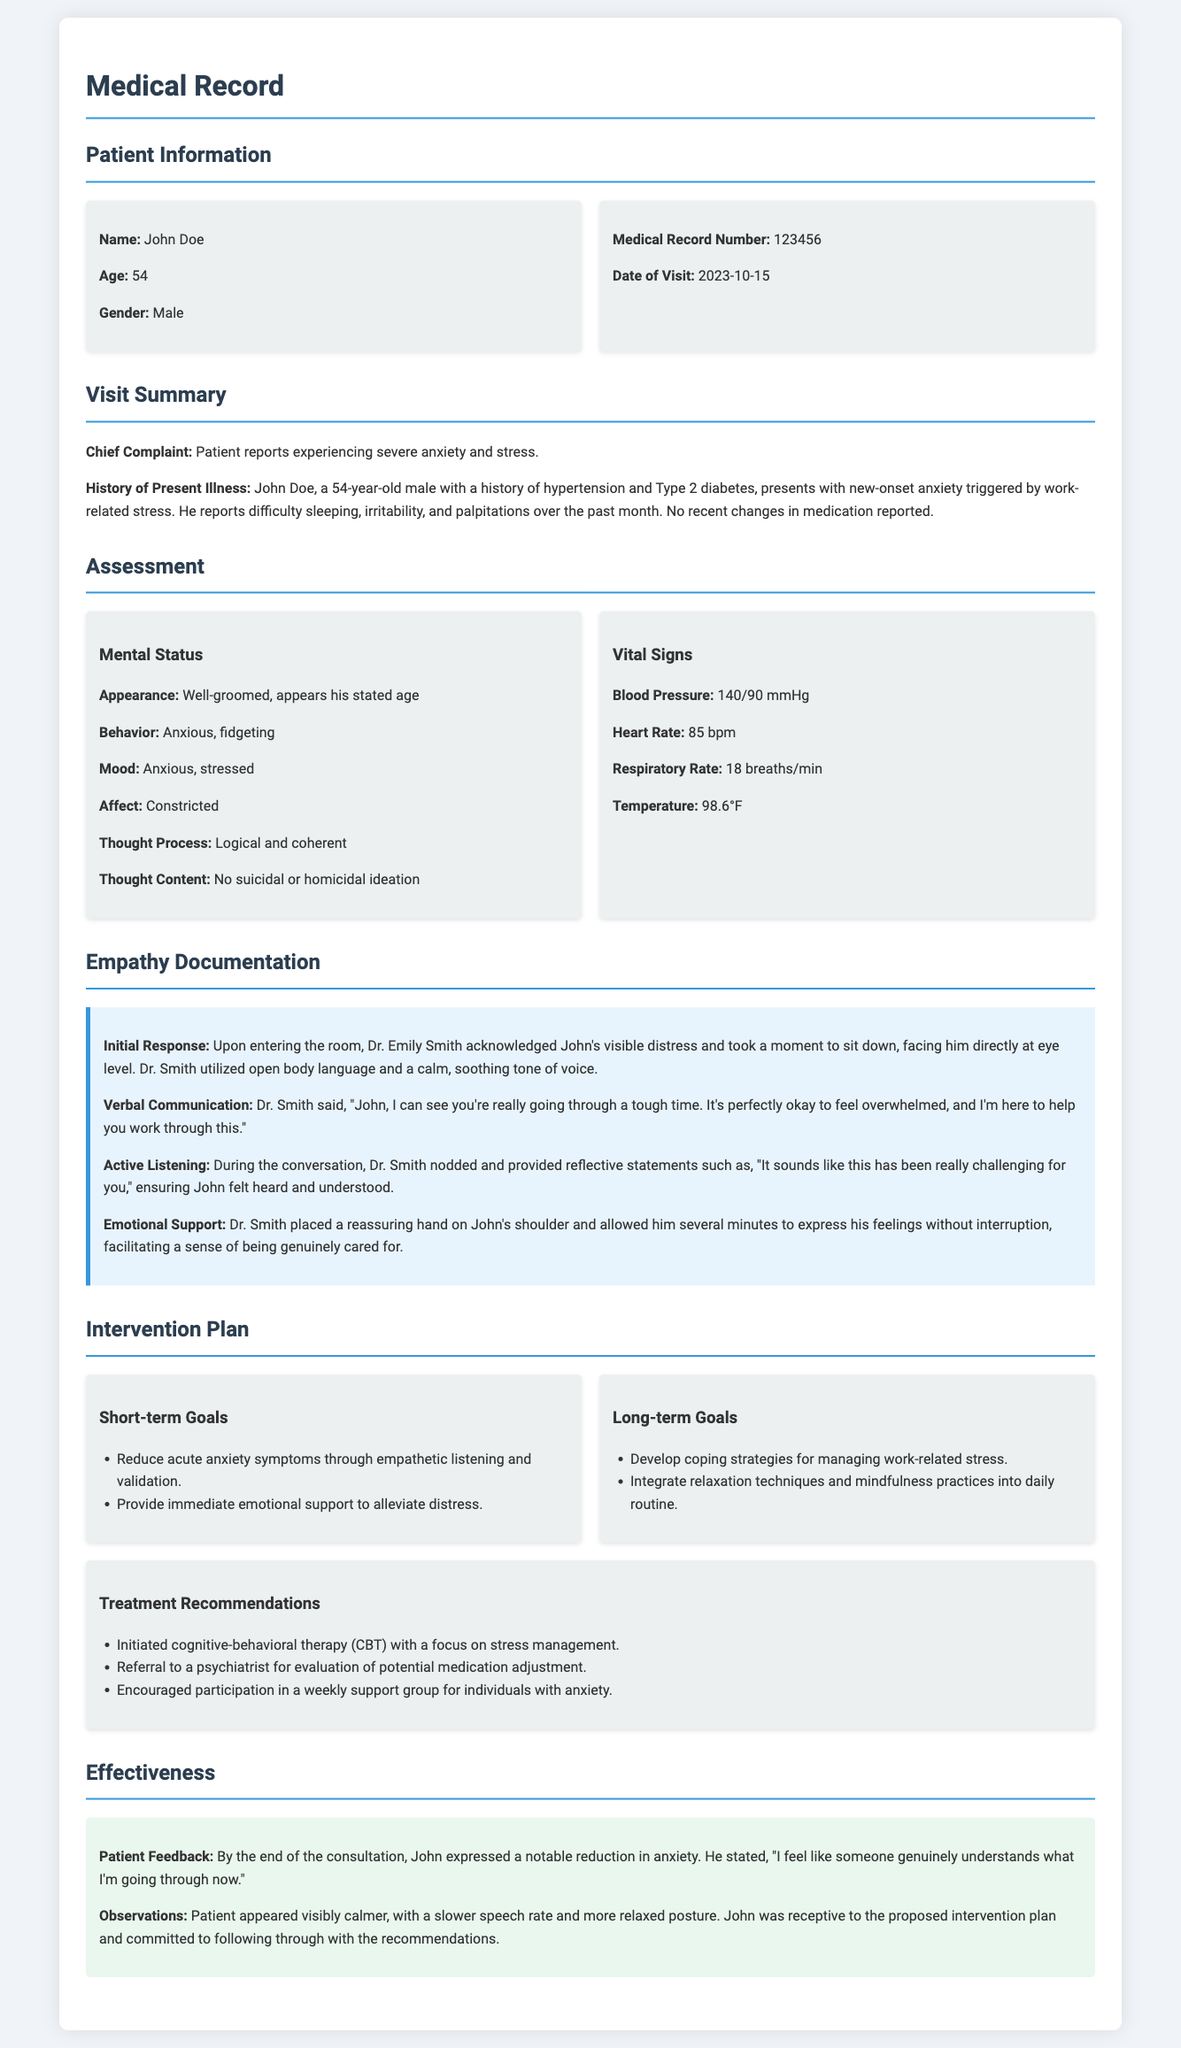What is the patient's name? The patient's name is listed in the document under Patient Information.
Answer: John Doe What is the chief complaint reported by the patient? The chief complaint is where the patient expresses their main issue during the visit.
Answer: Severe anxiety and stress What date did the visit occur? The date of the visit can be found in the Patient Information section.
Answer: 2023-10-15 Who is the attending physician? The attending physician is mentioned in the Empathy Documentation section.
Answer: Dr. Emily Smith What is the age of the patient? The patient's age is specifically stated in the Patient Information section.
Answer: 54 What emotional support was provided by the physician? The emotional support describes actions taken by the physician to comfort the patient.
Answer: Placed a reassuring hand on John's shoulder How did the patient feel by the end of the consultation? This question evaluates the patient's feedback about their emotional state after the visit.
Answer: Notable reduction in anxiety What is one of the long-term goals in the intervention plan? The long-term goals are outlined in the Intervention Plan section, focusing on future objectives for the patient's care.
Answer: Develop coping strategies for managing work-related stress What type of therapy was initiated for the patient? The type of therapy is specified in the Treatment Recommendations to guide the patient’s mental health care.
Answer: Cognitive-behavioral therapy (CBT) 